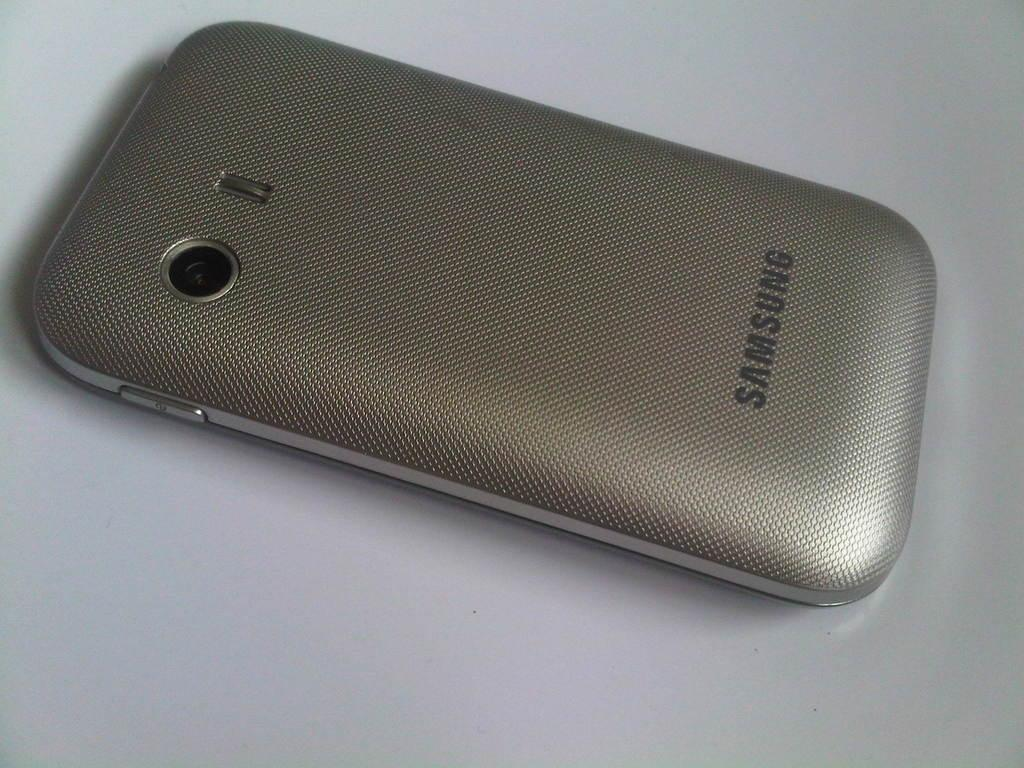<image>
Present a compact description of the photo's key features. A Samsung phone is lying face down on a white table. 